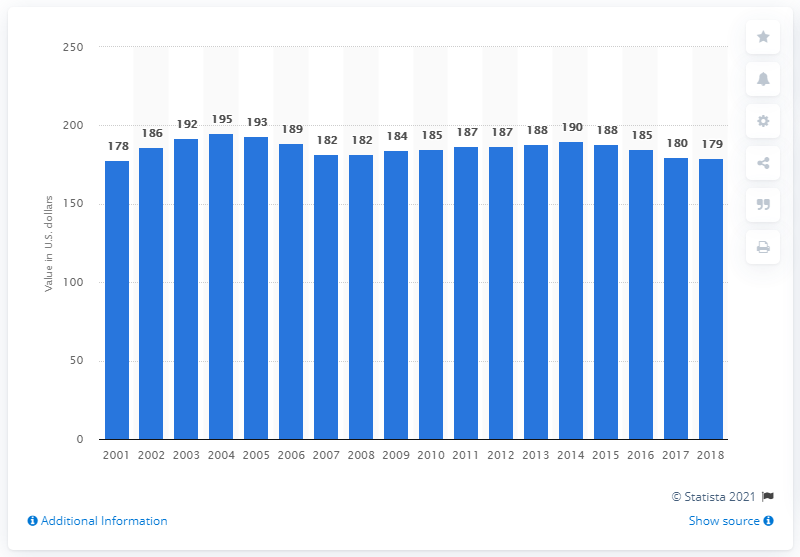Mention a couple of crucial points in this snapshot. In 2018, the average premium for renters insurance was 179. 